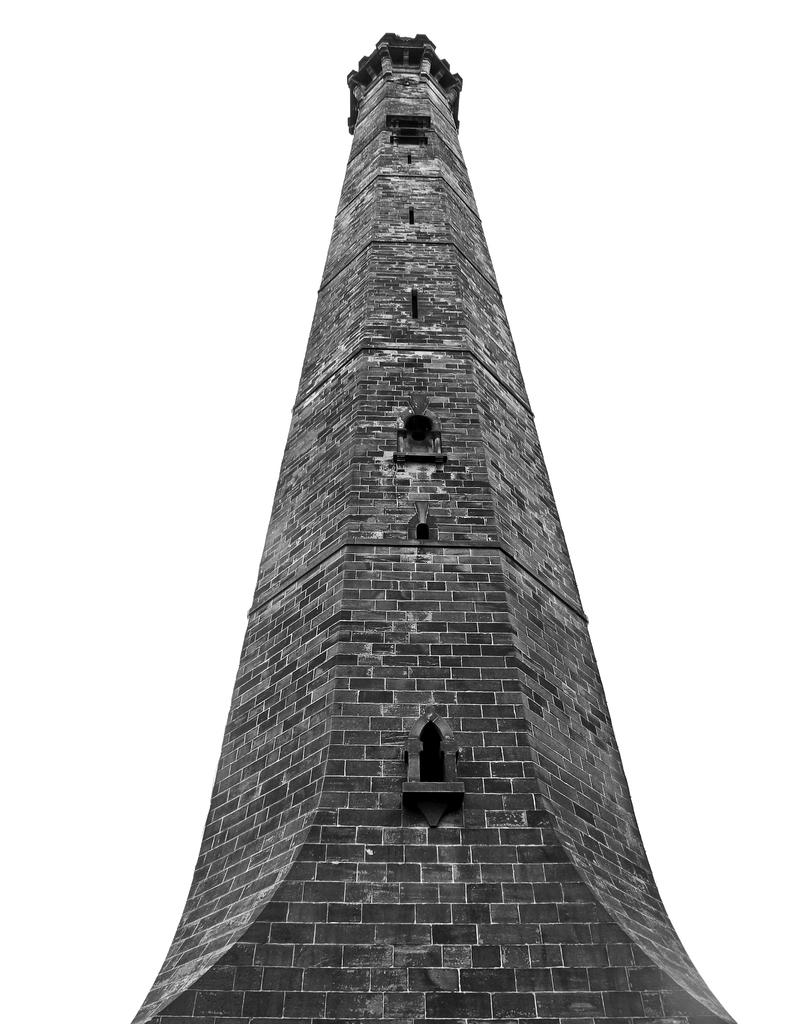What is the main structure visible in the image? There is a tower in the image. What is the condition of the sky in the image? The sky is clear in the image. What type of ground can be seen beneath the tower in the image? There is no specific ground visible beneath the tower in the image; only the tower and the sky are present. Are there any fowl visible in the image? There are no fowl visible in the image. What type of channel is present in the image? There is no channel present in the image. 